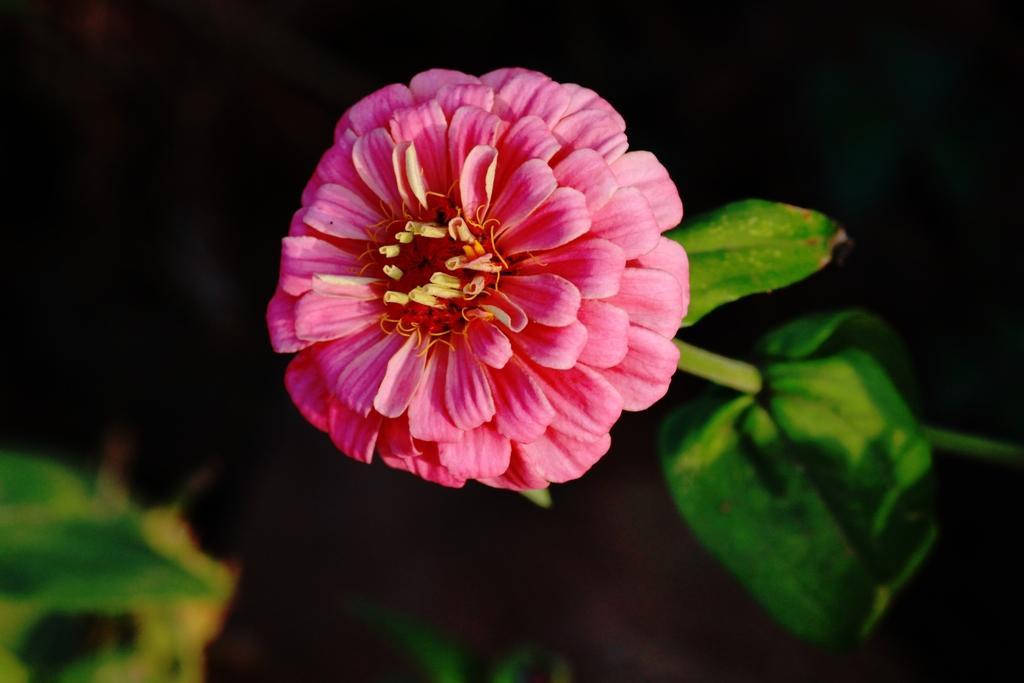Please provide a concise description of this image. In this image we can see a flower. And we can see the leaves. And we can see the black background. 